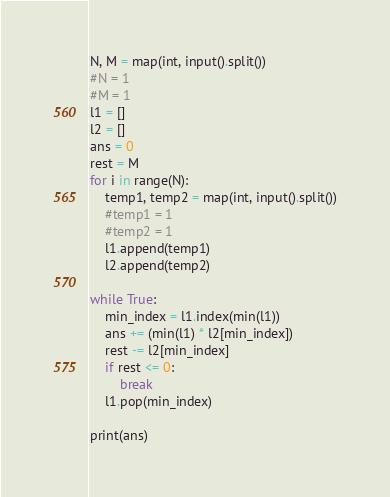<code> <loc_0><loc_0><loc_500><loc_500><_Python_>N, M = map(int, input().split())
#N = 1
#M = 1
l1 = []
l2 = []
ans = 0
rest = M
for i in range(N):
	temp1, temp2 = map(int, input().split())
	#temp1 = 1
	#temp2 = 1
	l1.append(temp1)
	l2.append(temp2)

while True:
	min_index = l1.index(min(l1))
	ans += (min(l1) * l2[min_index])
	rest -= l2[min_index]
	if rest <= 0:
		break
	l1.pop(min_index)

print(ans)</code> 